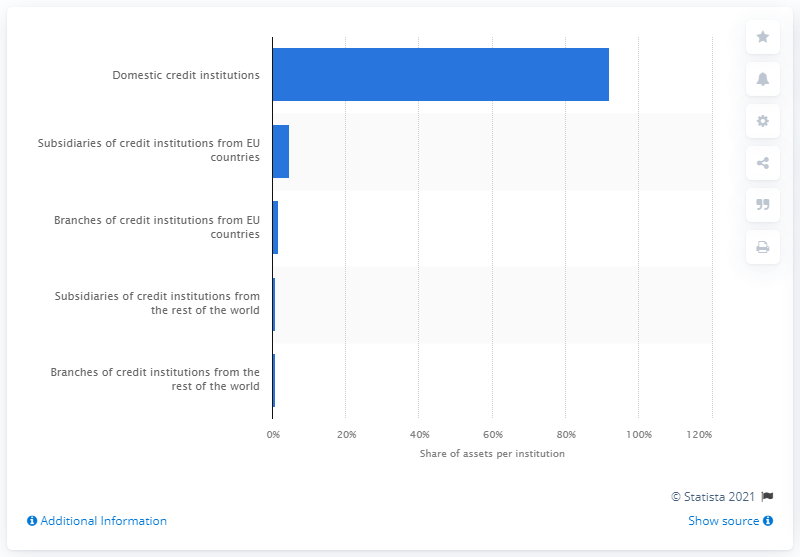Draw attention to some important aspects in this diagram. In 2016, a significant portion of France's banking assets, approximately 92%, were held by domestic credit institutions. 